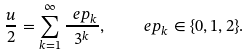<formula> <loc_0><loc_0><loc_500><loc_500>\frac { u } { 2 } = \sum _ { k = 1 } ^ { \infty } \frac { \ e p _ { k } } { 3 ^ { k } } , \quad \ e p _ { k } \in \{ 0 , 1 , 2 \} .</formula> 